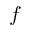Convert formula to latex. <formula><loc_0><loc_0><loc_500><loc_500>f</formula> 